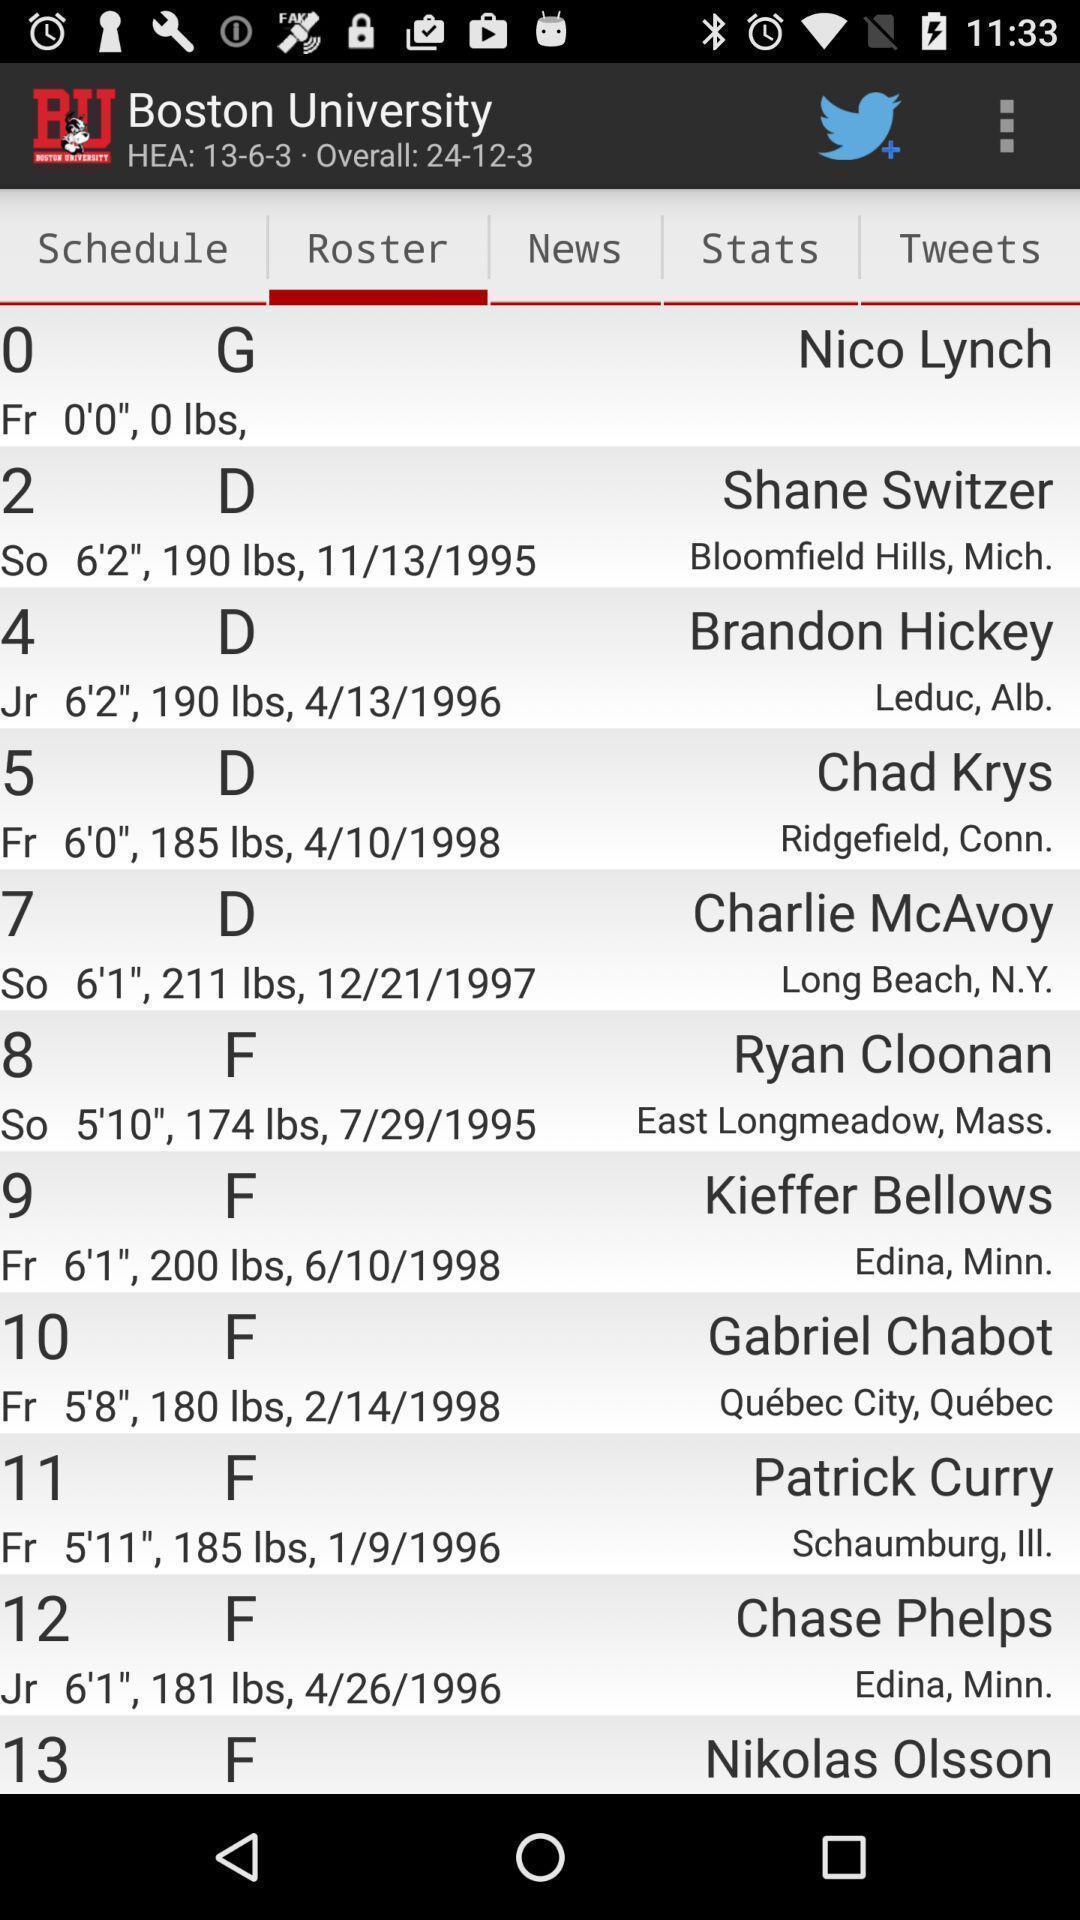Describe the visual elements of this screenshot. Screen shows several details available in a website. 